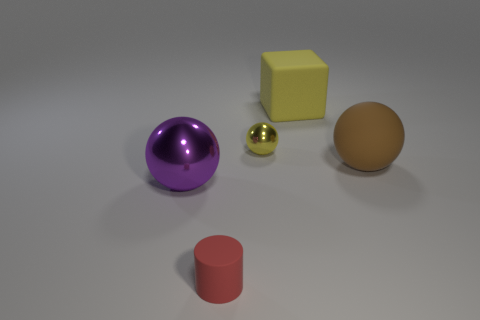How many things are either large things behind the brown ball or yellow rubber objects?
Offer a very short reply. 1. There is a red object; does it have the same size as the metallic object on the left side of the tiny yellow sphere?
Keep it short and to the point. No. What number of small things are brown things or purple metallic cylinders?
Keep it short and to the point. 0. The tiny matte thing has what shape?
Offer a very short reply. Cylinder. There is a matte thing that is the same color as the small ball; what is its size?
Make the answer very short. Large. Are there any things made of the same material as the cube?
Offer a very short reply. Yes. Are there more large shiny balls than tiny blue metallic balls?
Ensure brevity in your answer.  Yes. Do the tiny red object and the tiny yellow object have the same material?
Ensure brevity in your answer.  No. What number of rubber objects are either large spheres or small brown objects?
Provide a short and direct response. 1. The object that is the same size as the cylinder is what color?
Provide a short and direct response. Yellow. 